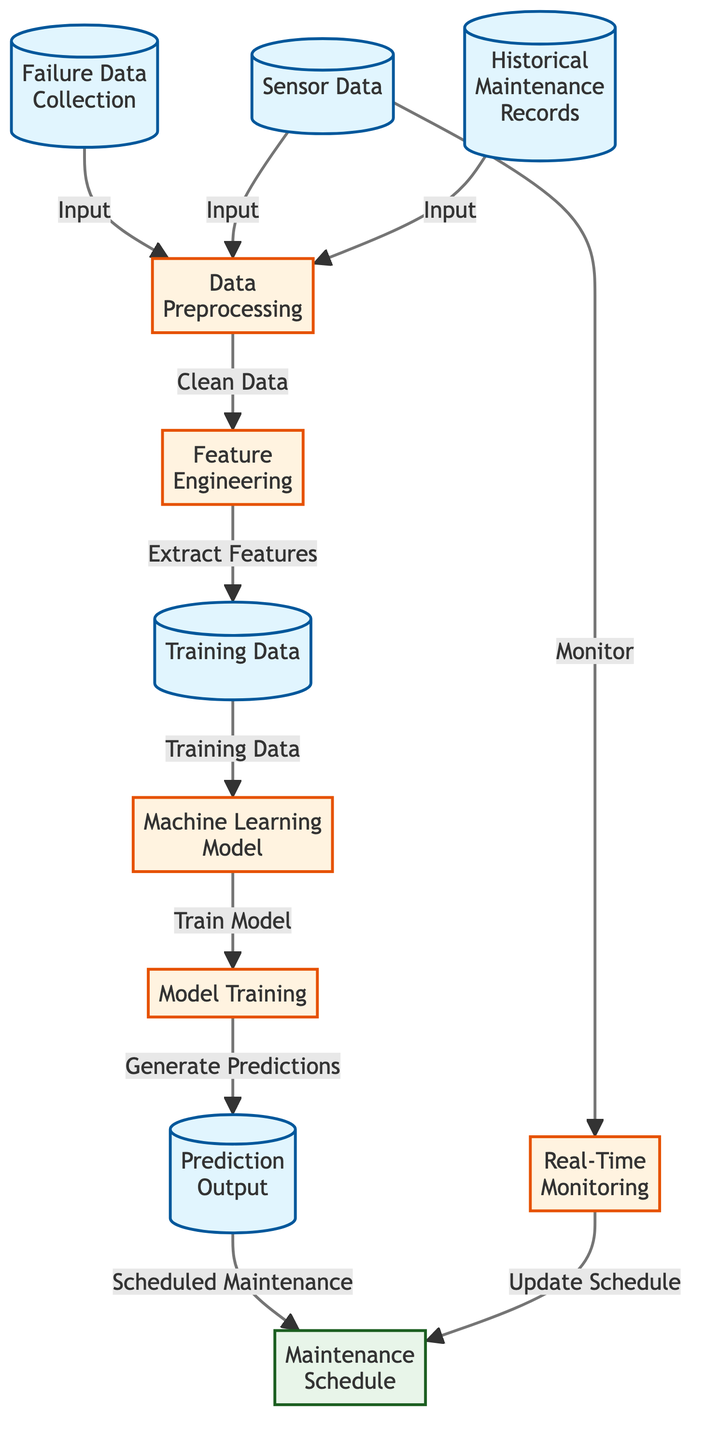What are the three types of data inputs in the diagram? The three types of data inputs listed in the diagram are "Failure Data Collection," "Sensor Data," and "Historical Maintenance Records." They are represented as nodes directly connected to the "Data Preprocessing" node, indicating they are all inputs for that process.
Answer: Failure Data Collection, Sensor Data, Historical Maintenance Records How many process nodes are present in the diagram? The diagram contains four process nodes: "Data Preprocessing," "Feature Engineering," "Machine Learning Model," and "Model Training." These nodes are highlighted as processes and indicate steps in the predictive maintenance scheduling flow.
Answer: Four What is the outcome produced by the "Prediction Output" node? The "Prediction Output" node is linked to the "Maintenance Schedule" node, signifying that the outcome generated from the predictions is utilized to create the scheduled maintenance.
Answer: Maintenance Schedule What type of data is produced after feature extraction? The diagram shows that after the "Feature Engineering" process, the output is labeled as "Training Data." This indicates that the extracted features are formatted into data suitable for training a machine learning model.
Answer: Training Data Which two nodes are responsible for updating the maintenance schedule? The "Real-Time Monitoring" node monitors the sensor data and has a direct link to "Maintenance Schedule," indicating that through monitoring, the schedule can be updated. These two nodes directly interact to reflect real-time conditions in the schedule.
Answer: Real-Time Monitoring, Maintenance Schedule What links the "Model Training" and "Prediction Output" nodes? The "Model Training" node generates predictions that are passed to the "Prediction Output" node. This connection signifies the flow of information from model training to the output predictions, forming a crucial aspect of the predictive maintenance process.
Answer: Generate Predictions How does sensor data interact with real-time monitoring? Sensor data is shown as an input to "Data Preprocessing" and is also linked directly to "Real-Time Monitoring," illustrating that this data is essential for both preparing the overall model and for ongoing monitoring, which helps update the maintenance schedule based on current conditions.
Answer: Monitor What is the main purpose of the "Machine Learning Model" node? The main purpose of the "Machine Learning Model" node is to utilize the training data for generating predictions regarding maintenance needs. It acts as a central piece of the process where the model learns from the training data so that it can make future predictions.
Answer: Generate Predictions 